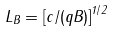<formula> <loc_0><loc_0><loc_500><loc_500>L _ { B } = \left [ c / ( q B ) \right ] ^ { 1 / 2 }</formula> 